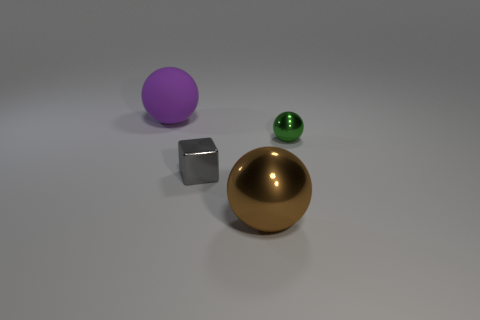Add 3 cyan cylinders. How many objects exist? 7 Subtract all blocks. How many objects are left? 3 Subtract all big purple matte balls. Subtract all tiny purple rubber objects. How many objects are left? 3 Add 4 brown things. How many brown things are left? 5 Add 1 big shiny balls. How many big shiny balls exist? 2 Subtract 0 cyan cubes. How many objects are left? 4 